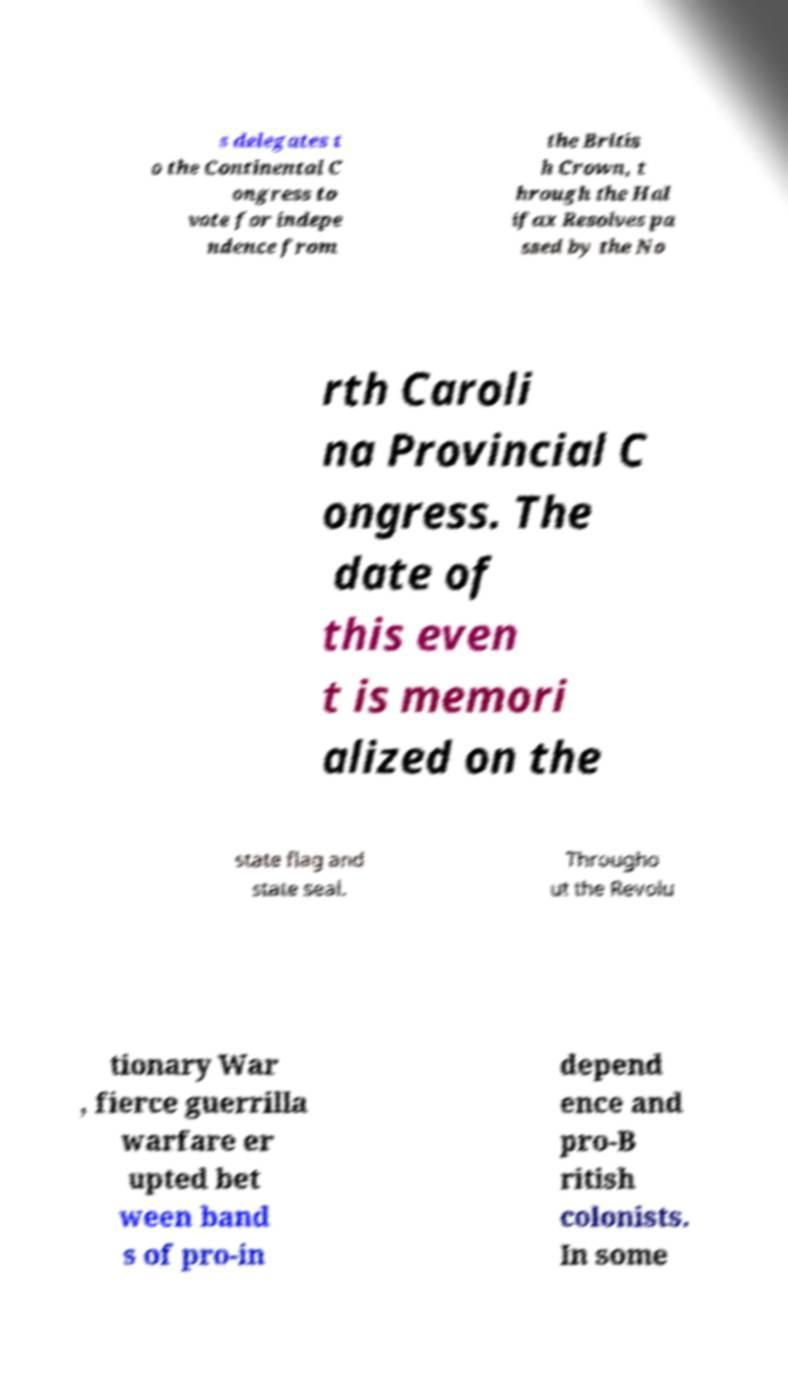Can you read and provide the text displayed in the image?This photo seems to have some interesting text. Can you extract and type it out for me? s delegates t o the Continental C ongress to vote for indepe ndence from the Britis h Crown, t hrough the Hal ifax Resolves pa ssed by the No rth Caroli na Provincial C ongress. The date of this even t is memori alized on the state flag and state seal. Througho ut the Revolu tionary War , fierce guerrilla warfare er upted bet ween band s of pro-in depend ence and pro-B ritish colonists. In some 